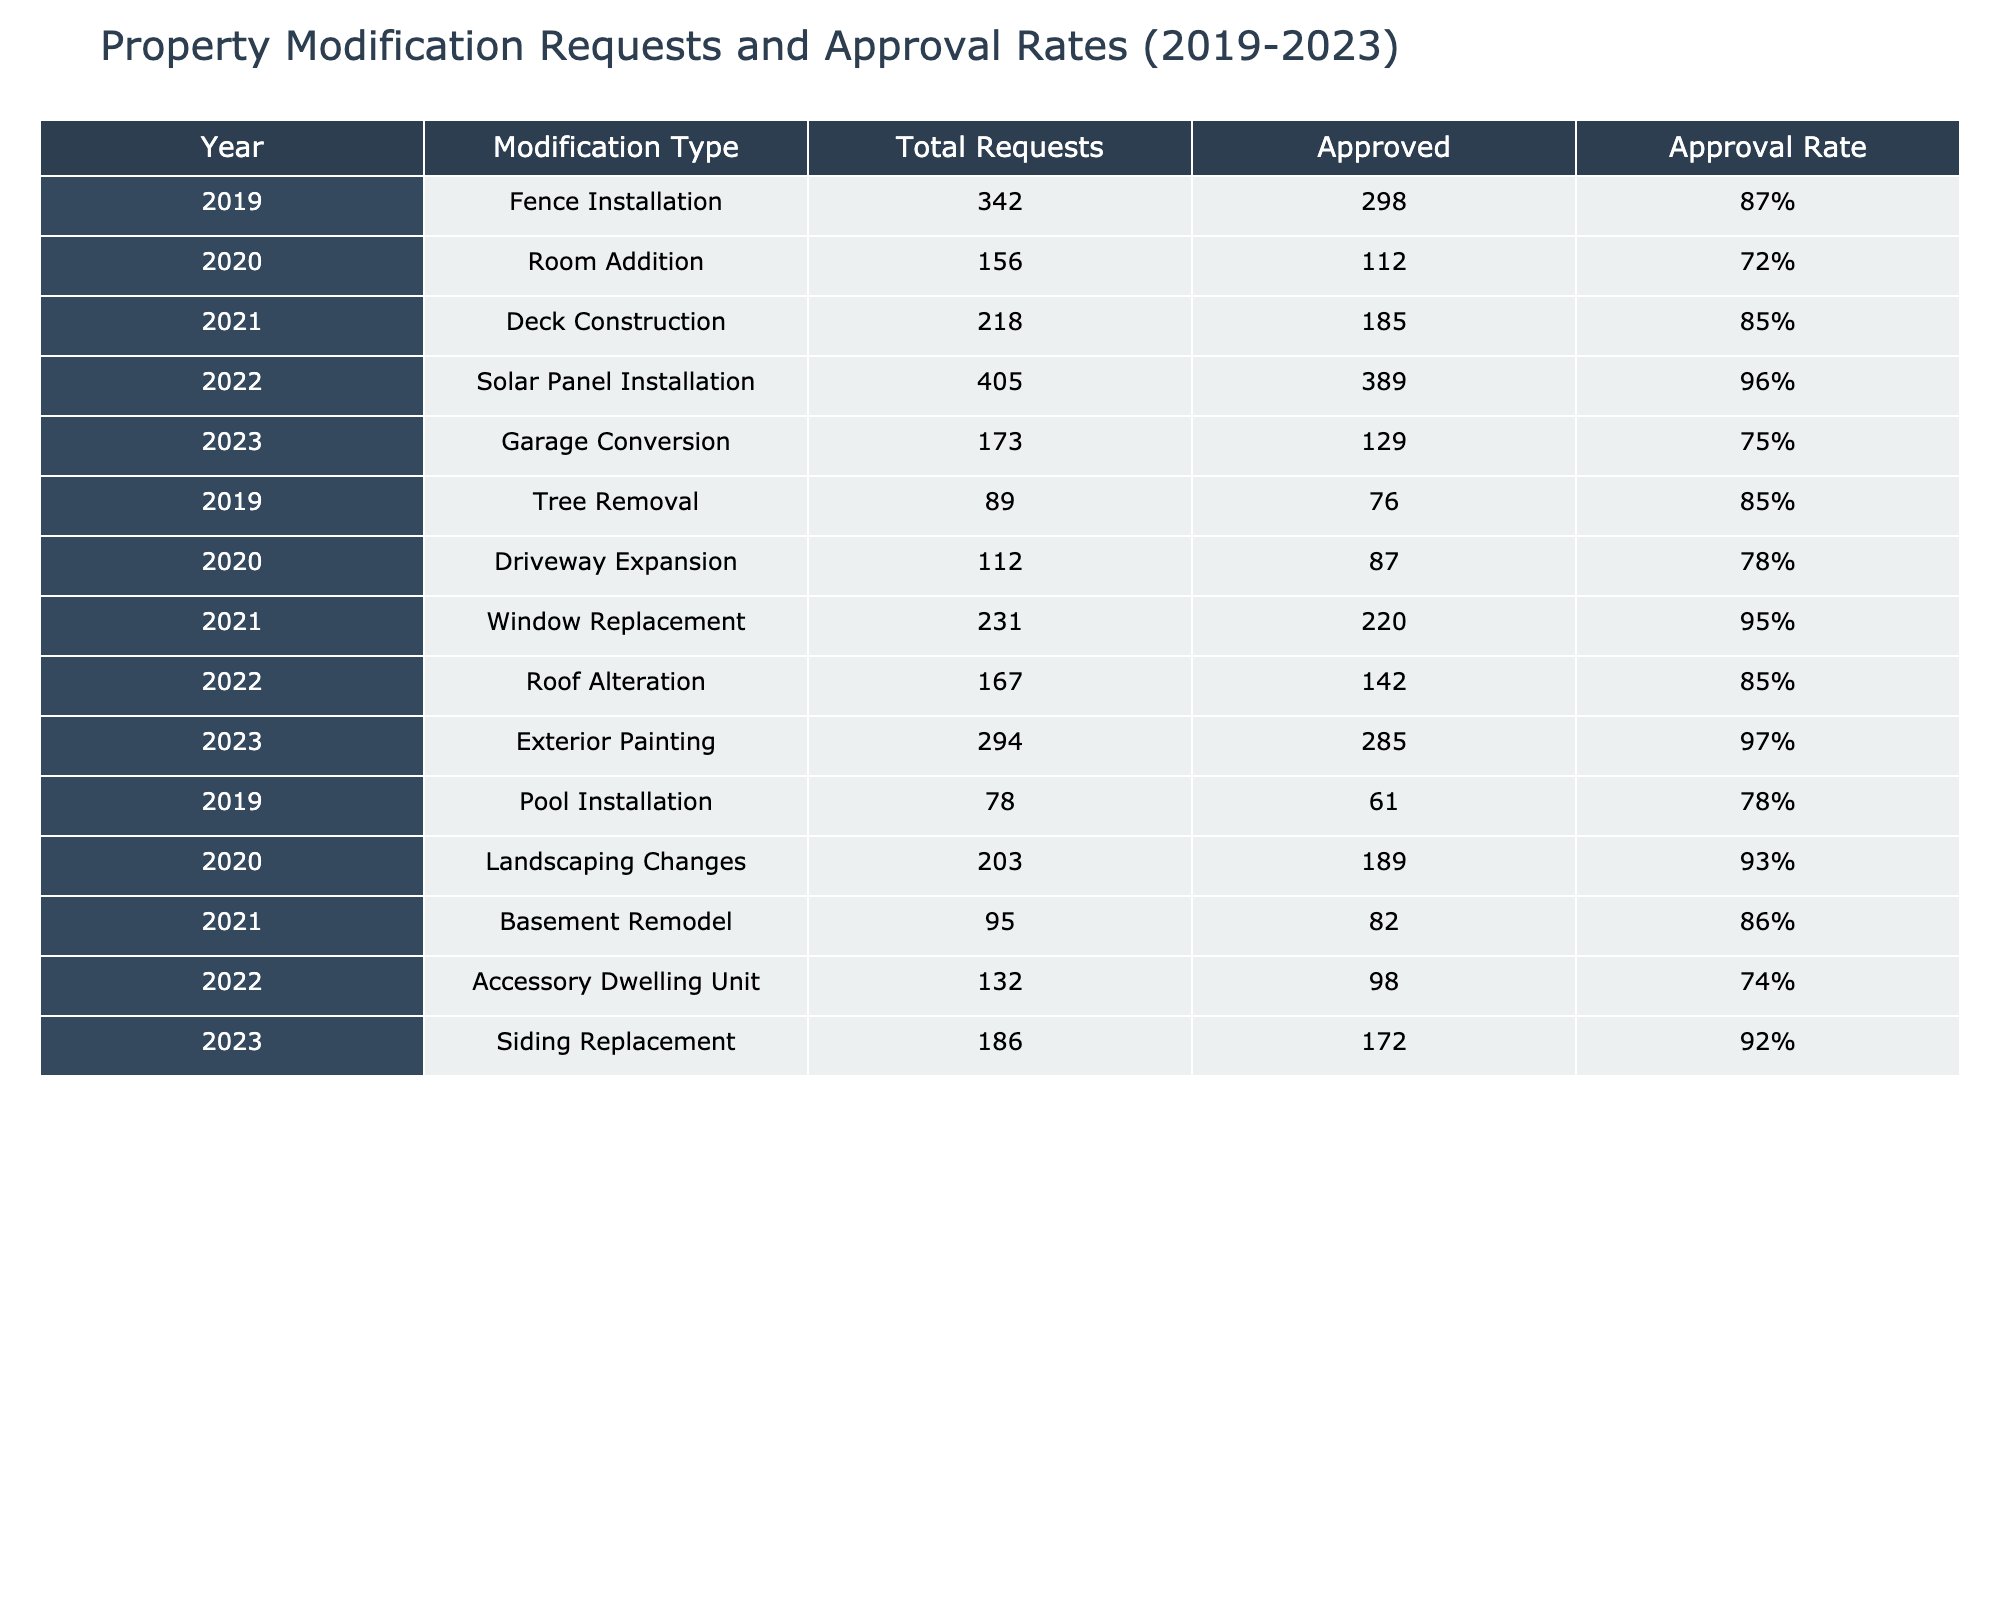What was the approval rate for Solar Panel Installation in 2022? The table shows that the approval rate for Solar Panel Installation in 2022 is listed as 96%.
Answer: 96% Which modification type had the highest approval rate in the last five years? By comparing the approval rates from each modification type, Solar Panel Installation in 2022 has the highest rate at 96%.
Answer: Solar Panel Installation in 2022 How many total requests were made for Garage Conversion in 2023? According to the table, the total requests for Garage Conversion in 2023 are 173.
Answer: 173 What is the average approval rate for all modification types from 2019 to 2023? To find the average approval rate, we sum all the approval rates: 87% + 72% + 85% + 96% + 75% + 85% + 78% + 95% + 85% + 97% + 78% + 93% + 86% + 74% + 92% = 1,392%. There are 15 modification types, so the average is 1,392% / 15 = 92.8%.
Answer: 92.8% Was the approval rate for Room Addition in 2020 higher or lower than that for Fence Installation in 2019? The approval rate for Room Addition in 2020 is 72%, while the rate for Fence Installation in 2019 is 87%. Since 72% is less than 87%, it is lower.
Answer: Lower What is the total number of approved requests for Deck Construction and Window Replacement from 2021? The number of approved requests for Deck Construction in 2021 is 185 and for Window Replacement is 220. Adding these gives 185 + 220 = 405.
Answer: 405 Which year had the least number of total requests for property modifications? By comparing the total requests for each year, the year with the least total requests is 2019, with 342 + 89 + 78 = 509 requests.
Answer: 2019 Is the approval rate for Tree Removal higher than 80%? The approval rate for Tree Removal in 2019 is 85%, which is indeed higher than 80%.
Answer: Yes How many more requests were made for Solar Panel Installation than Garage Conversion in 2023? There were 405 requests for Solar Panel Installation in 2022 and 173 requests for Garage Conversion in 2023. The difference is 405 - 173 = 232.
Answer: 232 In how many years did the approval rates exceed 90%? From the table, we see that the approval rates exceeded 90% in 2022 (Solar Panel Installation) and 2023 (Exterior Painting), which totals to 2 years.
Answer: 2 years What would be the approval rate if we merged the requests for what were originally two different types, like Tree Removal and Deck Construction? Tree Removal had an approval rate of 85% (76 approved out of 89 requests) and Deck Construction had 185 approved out of 218 requests, amounting to a rate of approximately 85% as well. Since both are the same, the merged rate would still be 85%.
Answer: 85% 